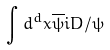<formula> <loc_0><loc_0><loc_500><loc_500>\int d ^ { d } x \overline { \psi } i D / \psi</formula> 